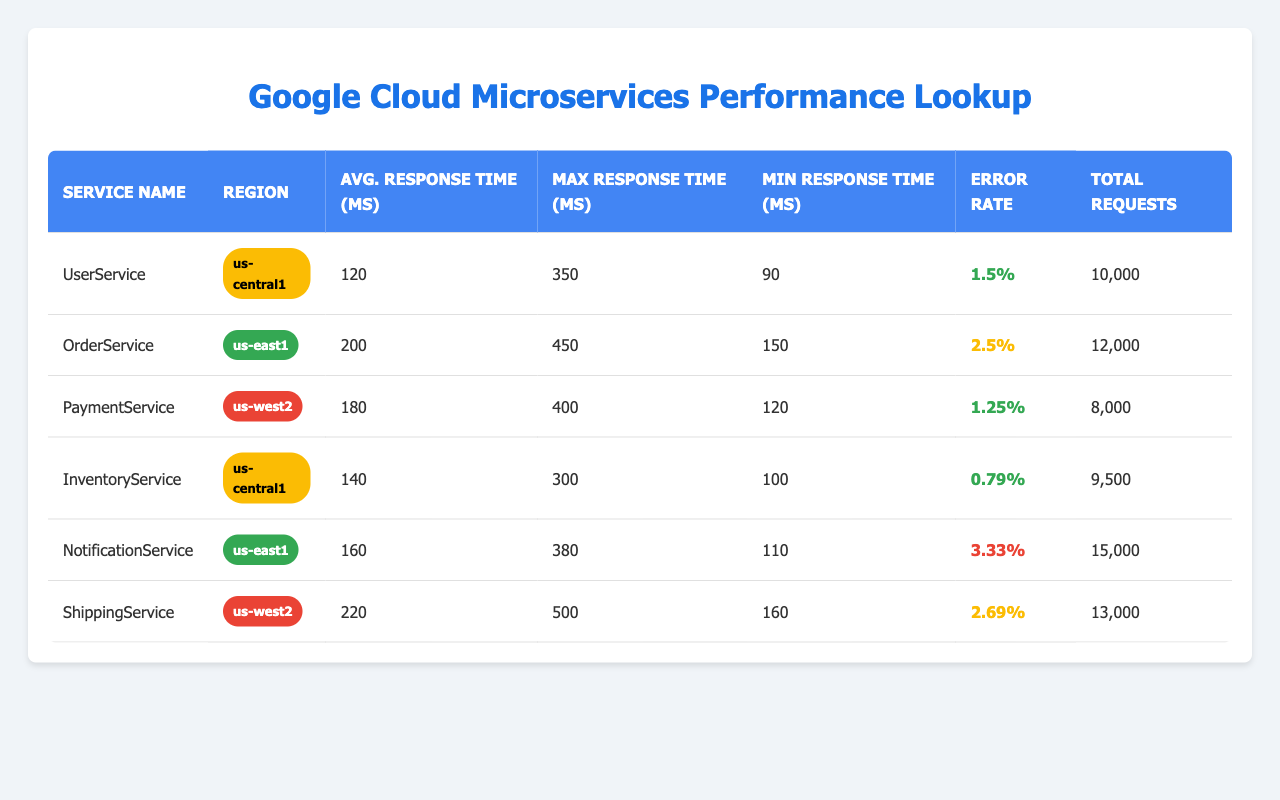What is the average response time for the ShippingService? The average response time for the ShippingService is listed in the table under the 'Avg. Response Time (ms)' column. It shows the value of 220 ms.
Answer: 220 ms Which service has the highest error rate? Reviewing the 'Error Rate' column, the NotificationService has the highest error rate listed, which is 3.33%.
Answer: NotificationService Calculate the average response time for all services combined. To find the average, first sum the average response times of all services: (120 + 200 + 180 + 140 + 160 + 220) = 1,120. Then, divide this total by the number of services: 1,120 / 6 = 186.67 ms
Answer: 186.67 ms Is the error rate of the InventoryService below 1%? The error rate for the InventoryService is recorded as 0.79%, which is indeed below 1%.
Answer: Yes How does the maximum response time for the OrderService compare to the average response time of the PaymentService? The maximum response time for the OrderService is 450 ms, while the average response time for the PaymentService is 180 ms. Since 450 ms is greater than 180 ms, the OrderService has a higher maximum response time than the PaymentService's average response time.
Answer: OrderService has a higher maximum response time What is the total number of requests made to the NotificationService? The 'Total Requests' column for the NotificationService shows 15,000 requests.
Answer: 15,000 requests Which region has the service with the lowest error rate? Looking at the 'Error Rate' values, the InventoryService, in the us-central1 region, has the lowest error rate at 0.79%. Therefore, the region us-central1 has the service with the lowest error rate.
Answer: us-central1 If we consider only the services in us-east1, what is their average response time? The services in the us-east1 region are the OrderService (average: 200 ms) and NotificationService (average: 160 ms). The total average response time is (200 + 160) = 360 ms. Dividing this by the number of services (2): 360 / 2 = 180 ms.
Answer: 180 ms 